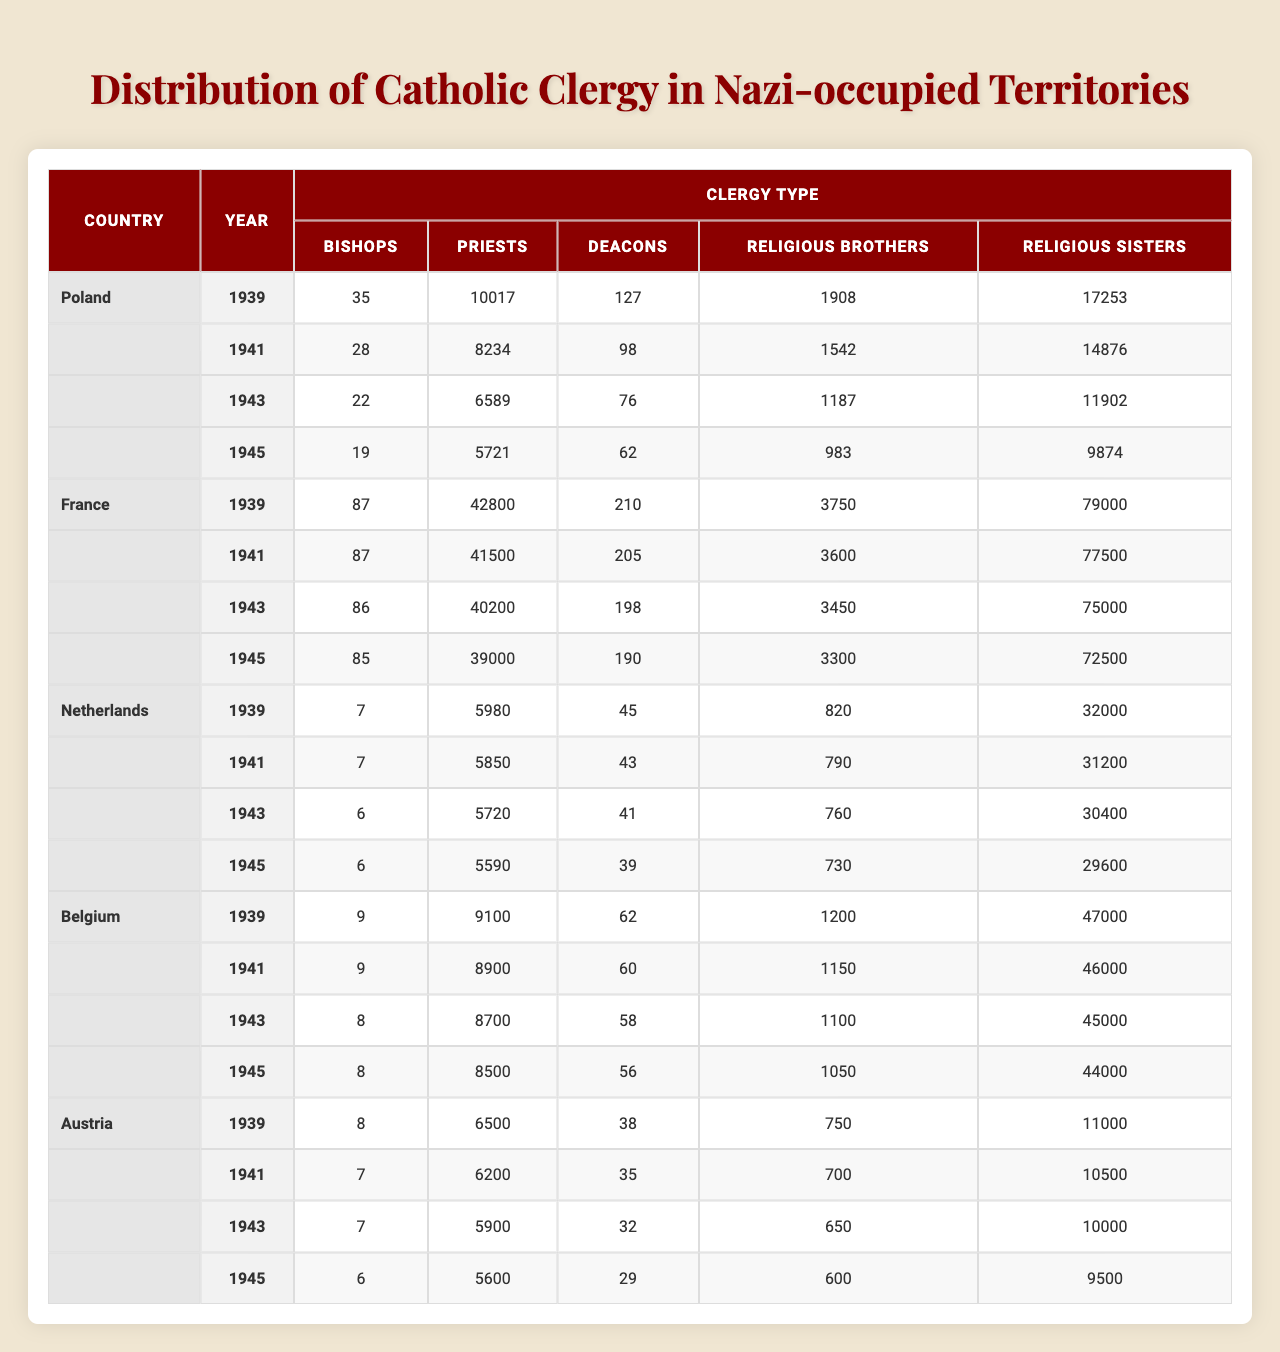What is the number of bishops in Poland in 1943? The table shows that Poland had 22 bishops in 1943, specifically listed under the column for bishops for that year.
Answer: 22 How many priests were there in France in 1939? The table indicates that France had 42,800 priests in 1939, specifically noted in the relevant cell for that country and year.
Answer: 42800 Which country had the highest number of religious sisters in 1945? By comparing the number of religious sisters for each country in 1945, it is evident that France had the highest count at 72,500.
Answer: France How many deacons were there in the Netherlands in 1941 compared to 1939? In 1941, the Netherlands had 43 deacons, whereas in 1939 it had 45. The difference is 45 - 43 = 2, indicating a decrease of 2 deacons over the two years.
Answer: Decrease of 2 What was the total number of religious brothers in Austria from 1939 to 1945? Summing the numbers over the years: 38 (1939) + 35 (1941) + 32 (1943) + 29 (1945) = 134. This gives a total of 134 religious brothers in the specified period for Austria.
Answer: 134 Did the number of bishops in Belgium decrease between 1939 and 1945? Checking the values, one sees that Belgium had 9 bishops in 1939 and 8 in 1945, indicating a decrease of 1 bishop over the years.
Answer: Yes What is the average number of priests across all countries in 1943? The number of priests in 1943 is as follows: Poland (6589), France (40200), Netherlands (5720), Belgium (8700), Austria (5900). Adding these values gives 6589 + 40200 + 5720 + 8700 + 5900 = 60529. Dividing by 5 yields an average of 12105.8.
Answer: 12105.8 Which country had the lowest number of religious brothers in 1941? The counts for religious brothers in 1941 were: Poland (1542), France (3600), Netherlands (790), Belgium (1150), Austria (700). The Netherlands had the lowest at 790.
Answer: Netherlands What was the trend in the number of religious sisters in Poland from 1939 to 1945? In looking at the data, the number of religious sisters in Poland decreased from 17253 in 1939 to 9874 by 1945. This shows a decline, specifically indicating loss in personnel over time.
Answer: Decrease Compare the number of priests in Belgium in 1943 with the number in Austria in the same year. Belgium had 8700 priests in 1943, whereas Austria had 5900. The comparison shows Belgium had 2800 more priests than Austria in that year.
Answer: 2800 more priests in Belgium 